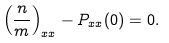<formula> <loc_0><loc_0><loc_500><loc_500>\left ( \frac { n } { m } \right ) _ { x x } - P _ { x x } ( 0 ) = 0 .</formula> 